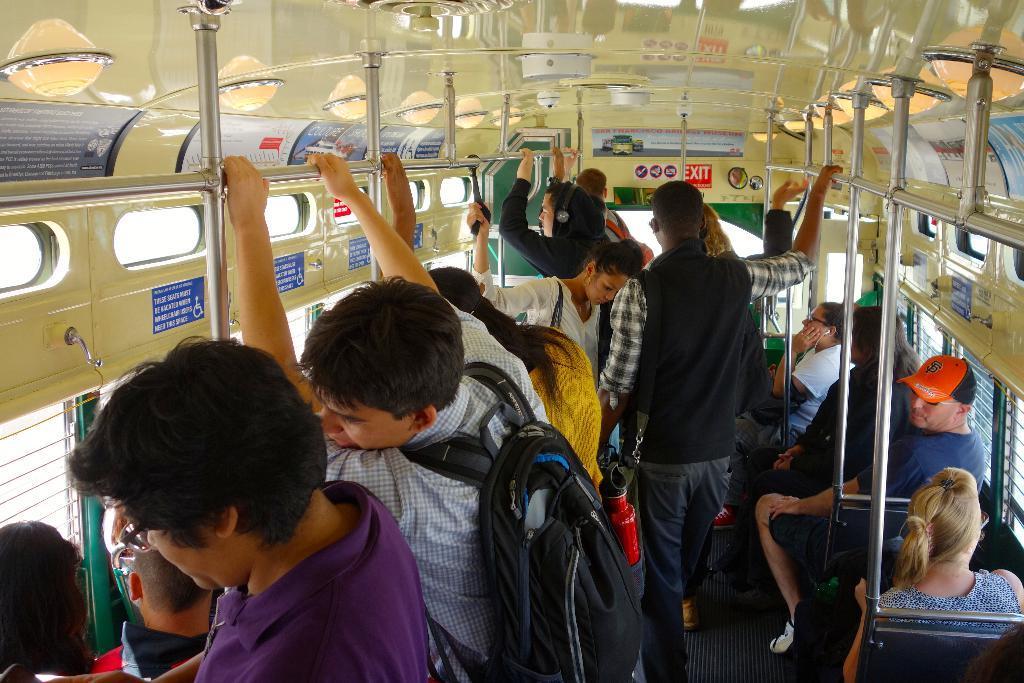Could you give a brief overview of what you see in this image? In this image there are a few people standing and sitting in inside the bus, there is some text on the poster which is attached to the bus. At the top of the image there are few lights and there are few poles. On the right and left side of the bus there are windows. 